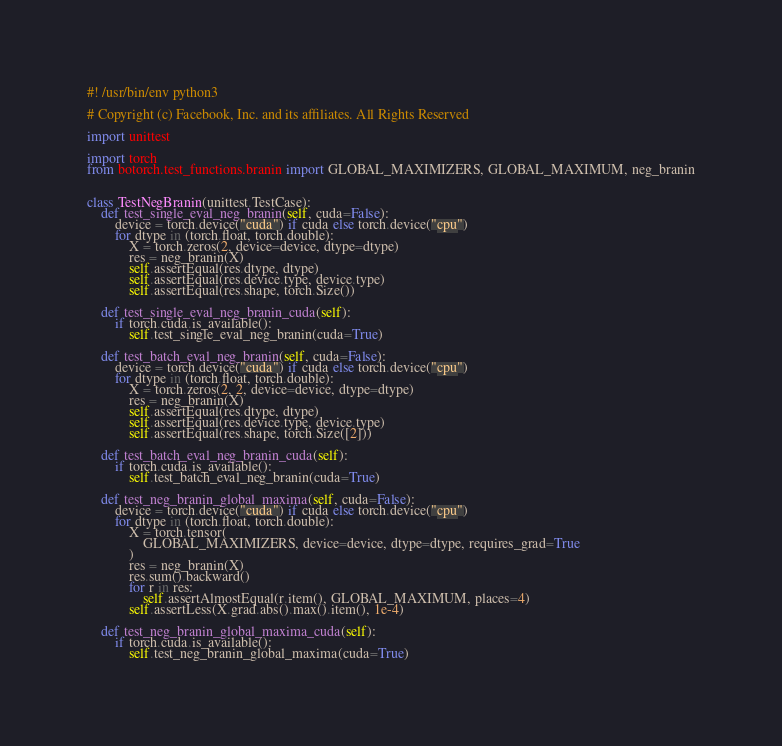<code> <loc_0><loc_0><loc_500><loc_500><_Python_>#! /usr/bin/env python3

# Copyright (c) Facebook, Inc. and its affiliates. All Rights Reserved

import unittest

import torch
from botorch.test_functions.branin import GLOBAL_MAXIMIZERS, GLOBAL_MAXIMUM, neg_branin


class TestNegBranin(unittest.TestCase):
    def test_single_eval_neg_branin(self, cuda=False):
        device = torch.device("cuda") if cuda else torch.device("cpu")
        for dtype in (torch.float, torch.double):
            X = torch.zeros(2, device=device, dtype=dtype)
            res = neg_branin(X)
            self.assertEqual(res.dtype, dtype)
            self.assertEqual(res.device.type, device.type)
            self.assertEqual(res.shape, torch.Size())

    def test_single_eval_neg_branin_cuda(self):
        if torch.cuda.is_available():
            self.test_single_eval_neg_branin(cuda=True)

    def test_batch_eval_neg_branin(self, cuda=False):
        device = torch.device("cuda") if cuda else torch.device("cpu")
        for dtype in (torch.float, torch.double):
            X = torch.zeros(2, 2, device=device, dtype=dtype)
            res = neg_branin(X)
            self.assertEqual(res.dtype, dtype)
            self.assertEqual(res.device.type, device.type)
            self.assertEqual(res.shape, torch.Size([2]))

    def test_batch_eval_neg_branin_cuda(self):
        if torch.cuda.is_available():
            self.test_batch_eval_neg_branin(cuda=True)

    def test_neg_branin_global_maxima(self, cuda=False):
        device = torch.device("cuda") if cuda else torch.device("cpu")
        for dtype in (torch.float, torch.double):
            X = torch.tensor(
                GLOBAL_MAXIMIZERS, device=device, dtype=dtype, requires_grad=True
            )
            res = neg_branin(X)
            res.sum().backward()
            for r in res:
                self.assertAlmostEqual(r.item(), GLOBAL_MAXIMUM, places=4)
            self.assertLess(X.grad.abs().max().item(), 1e-4)

    def test_neg_branin_global_maxima_cuda(self):
        if torch.cuda.is_available():
            self.test_neg_branin_global_maxima(cuda=True)
</code> 